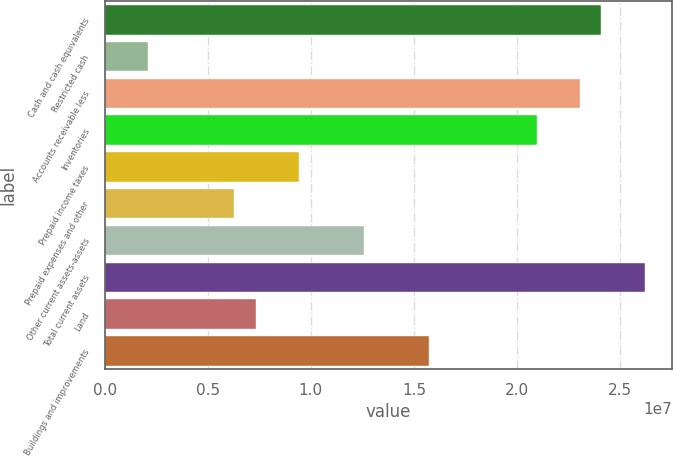Convert chart. <chart><loc_0><loc_0><loc_500><loc_500><bar_chart><fcel>Cash and cash equivalents<fcel>Restricted cash<fcel>Accounts receivable less<fcel>Inventories<fcel>Prepaid income taxes<fcel>Prepaid expenses and other<fcel>Other current assets-assets<fcel>Total current assets<fcel>Land<fcel>Buildings and improvements<nl><fcel>2.40954e+07<fcel>2.09664e+06<fcel>2.30478e+07<fcel>2.09527e+07<fcel>9.42955e+06<fcel>6.28687e+06<fcel>1.25722e+07<fcel>2.61905e+07<fcel>7.33443e+06<fcel>1.57149e+07<nl></chart> 